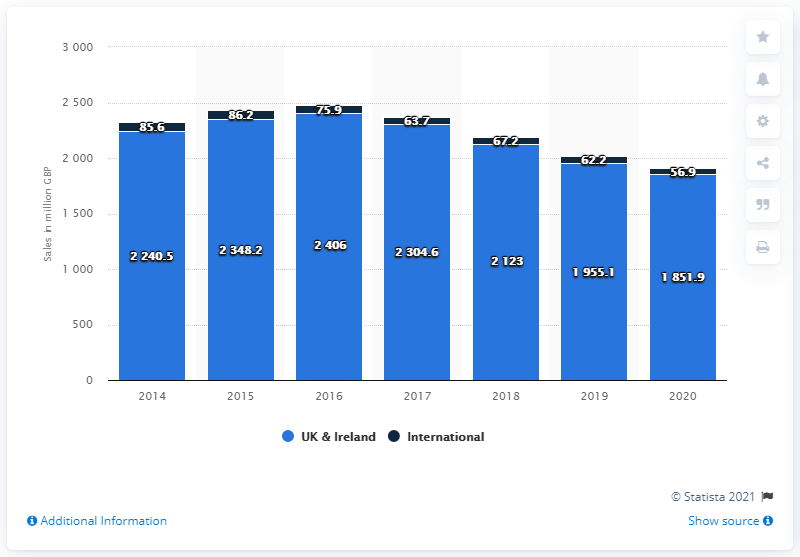What additional information might be provided in the source linked on the bar chart? The source linked in the bar chart likely provides more detailed financial data and analysis about Next plc's performance. This might include breakdowns of sales by product category, more comprehensive international sales data, insights into profitability, market trends, and explanations for the changes in revenue over time. It may also contain forward-looking statements and strategy information about Next plc's future. 